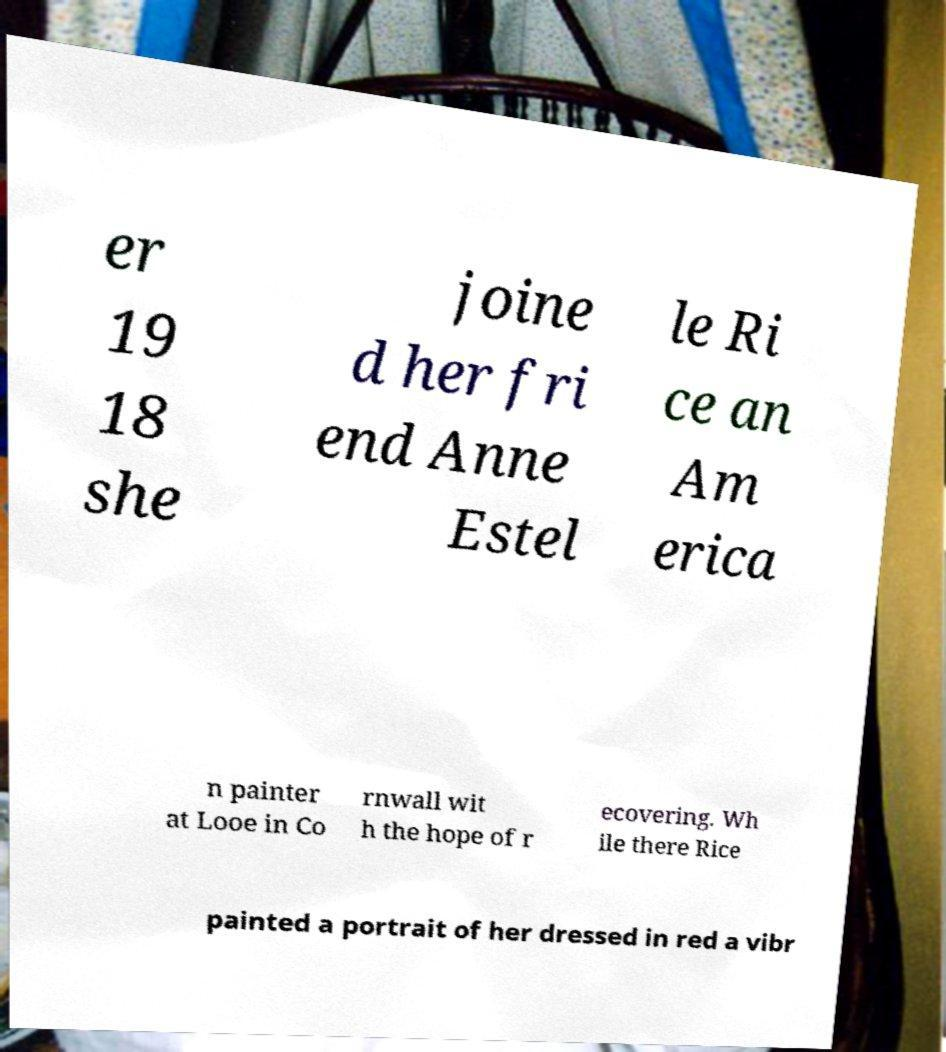Please read and relay the text visible in this image. What does it say? er 19 18 she joine d her fri end Anne Estel le Ri ce an Am erica n painter at Looe in Co rnwall wit h the hope of r ecovering. Wh ile there Rice painted a portrait of her dressed in red a vibr 